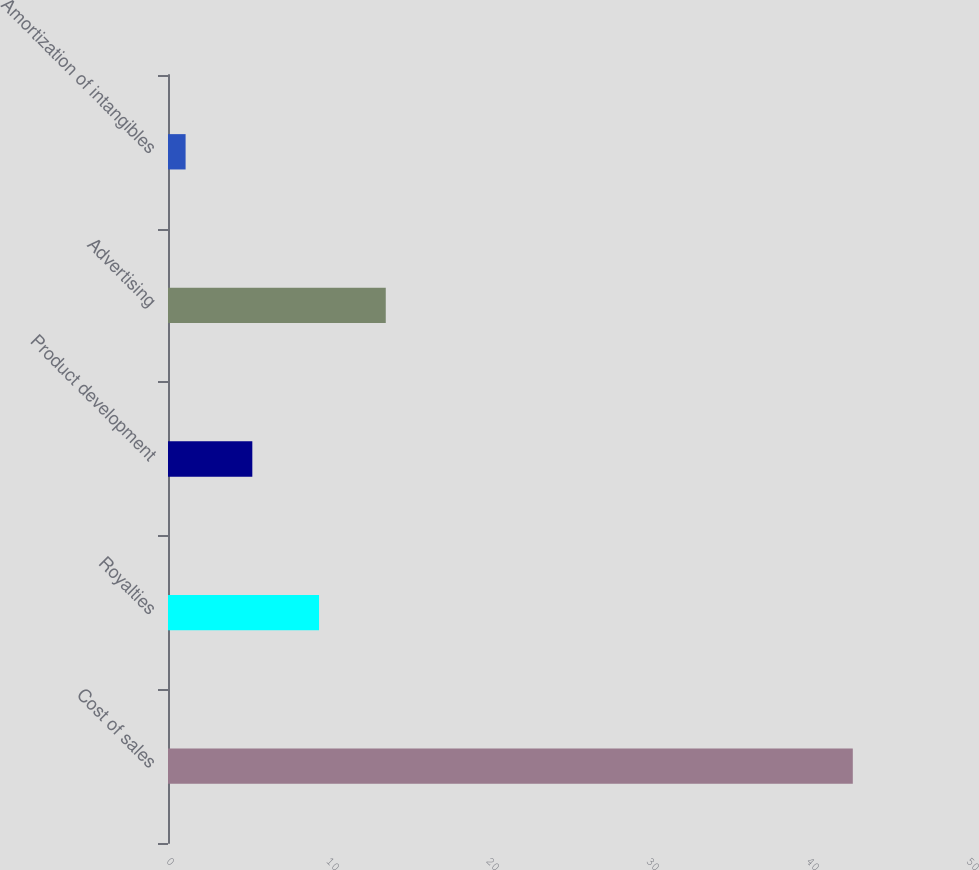Convert chart. <chart><loc_0><loc_0><loc_500><loc_500><bar_chart><fcel>Cost of sales<fcel>Royalties<fcel>Product development<fcel>Advertising<fcel>Amortization of intangibles<nl><fcel>42.8<fcel>9.44<fcel>5.27<fcel>13.61<fcel>1.1<nl></chart> 